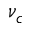<formula> <loc_0><loc_0><loc_500><loc_500>\nu _ { c }</formula> 